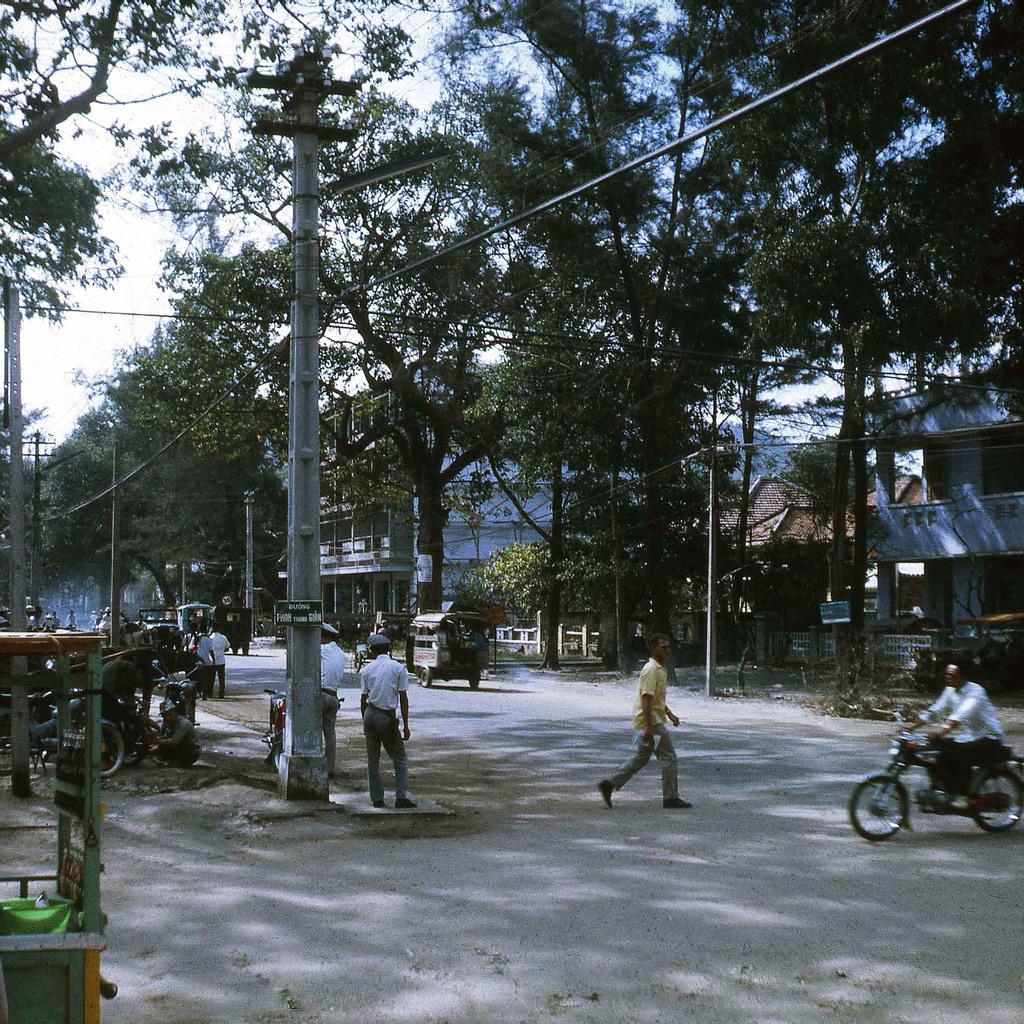Can you describe this image briefly? In this image I can see a few persons on the road. The person is riding a bike. There is a building and a trees. 